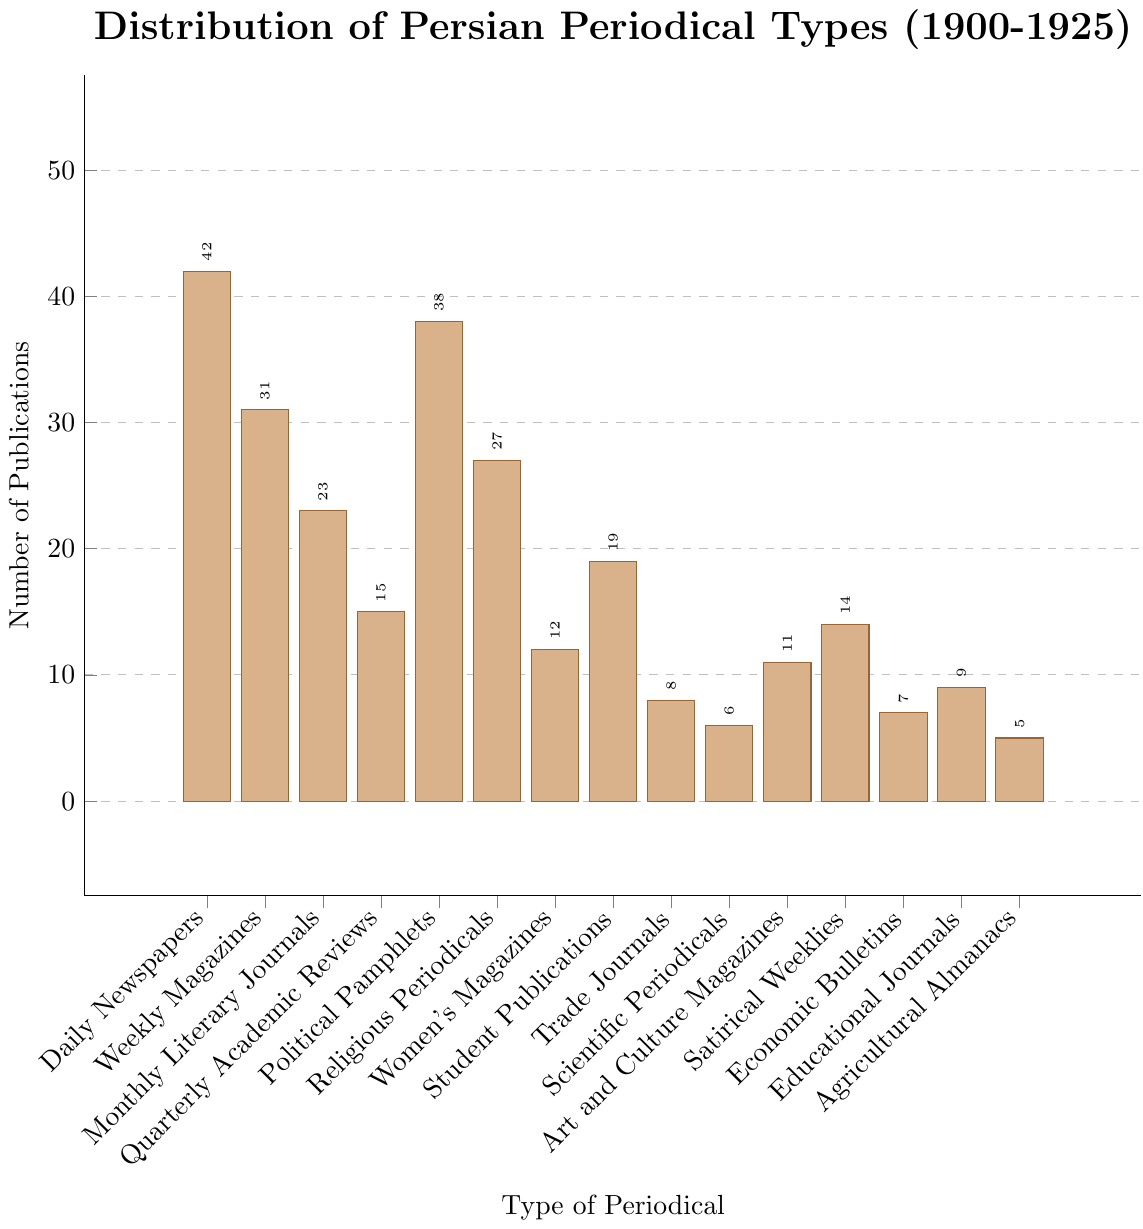Which type of periodical has the highest number of publications? To determine which type of periodical has the highest number of publications, we examine the heights of the bars in the chart and find the one that reaches the highest value. The bar for "Daily Newspapers" is the tallest, reaching 42 publications.
Answer: Daily Newspapers Which periodical type has more publications: Women's Magazines or Art and Culture Magazines? Compare the height of the bars for Women's Magazines and Art and Culture Magazines. The bar for Women's Magazines is slightly taller at 12 publications, whereas Art and Culture Magazines have 11 publications.
Answer: Women's Magazines What is the total number of publications for Political Pamphlets and Student Publications combined? Sum the number of publications for Political Pamphlets (38) and Student Publications (19). The operation is 38 + 19 = 57.
Answer: 57 How many fewer publications are there in Scientific Periodicals compared to Monthly Literary Journals? Subtract the number of publications of Scientific Periodicals (6) from Monthly Literary Journals (23). The operation is 23 - 6 = 17.
Answer: 17 Which three periodical types have the least publications? Identify the three shortest bars in the chart, corresponding to the periodicals with the least publications. These are Agricultural Almanacs (5), Scientific Periodicals (6), and Economic Bulletins (7).
Answer: Agricultural Almanacs, Scientific Periodicals, Economic Bulletins What is the average number of publications for the periodical types Political Pamphlets, Religious Periodicals, and Weekly Magazines? First, sum the numbers of publications for Political Pamphlets (38), Religious Periodicals (27), and Weekly Magazines (31). The operation is 38 + 27 + 31 = 96. Then, divide the sum by 3 to find the average: 96 / 3 = 32.
Answer: 32 Are there more daily newspapers or monthly literary journals? Compare the number of publications for Daily Newspapers (42) and Monthly Literary Journals (23). Daily Newspapers have more publications.
Answer: Daily Newspapers What is the difference in the number of publications between Quarterly Academic Reviews and Educational Journals? Subtract the number of publications of Educational Journals (9) from Quarterly Academic Reviews (15). The operation is 15 - 9 = 6.
Answer: 6 What percentage of the total periodicals are Daily Newspapers? First, find the total number of periodicals by summing all the publication numbers: 42 + 31 + 23 + 15 + 38 + 27 + 12 + 19 + 8 + 6 + 11 + 14 + 7 + 9 + 5 = 267. Then, compute the percentage for Daily Newspapers: (42 / 267) × 100 ≈ 15.73%.
Answer: Approximately 15.73% If you add the number of Women's Magazines and Student Publications, does it exceed the number of Weekly Magazines? Sum the publications for Women's Magazines (12) and Student Publications (19): 12 + 19 = 31. Compare this sum to the number of Weekly Magazines (31). They are equal and do not exceed.
Answer: No 